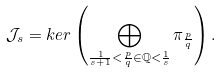<formula> <loc_0><loc_0><loc_500><loc_500>\mathcal { J } _ { s } = k e r \left ( \bigoplus _ { \frac { 1 } { s + 1 } < \frac { p } { q } \in \mathbb { Q } < \frac { 1 } { s } } \pi _ { \frac { p } { q } } \right ) .</formula> 